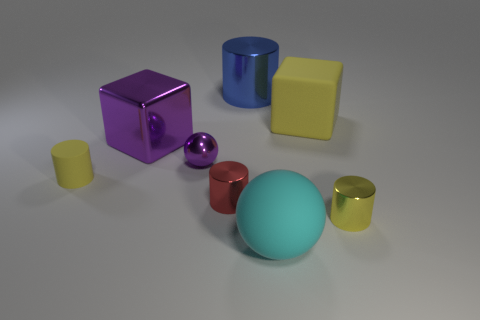Subtract all brown cylinders. Subtract all gray cubes. How many cylinders are left? 4 Add 1 large brown cylinders. How many objects exist? 9 Subtract all balls. How many objects are left? 6 Add 2 tiny yellow objects. How many tiny yellow objects are left? 4 Add 5 tiny blue matte objects. How many tiny blue matte objects exist? 5 Subtract 0 brown blocks. How many objects are left? 8 Subtract all tiny blue blocks. Subtract all tiny yellow cylinders. How many objects are left? 6 